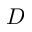<formula> <loc_0><loc_0><loc_500><loc_500>D</formula> 